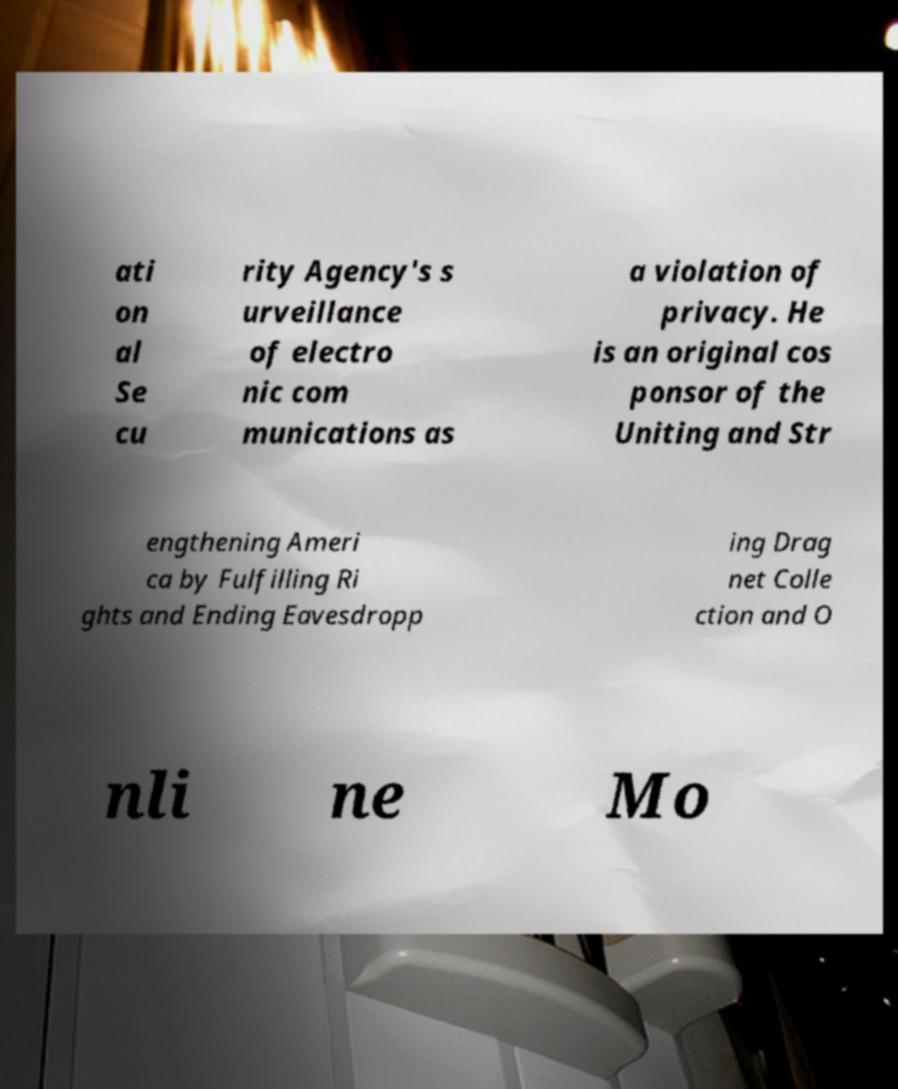I need the written content from this picture converted into text. Can you do that? ati on al Se cu rity Agency's s urveillance of electro nic com munications as a violation of privacy. He is an original cos ponsor of the Uniting and Str engthening Ameri ca by Fulfilling Ri ghts and Ending Eavesdropp ing Drag net Colle ction and O nli ne Mo 